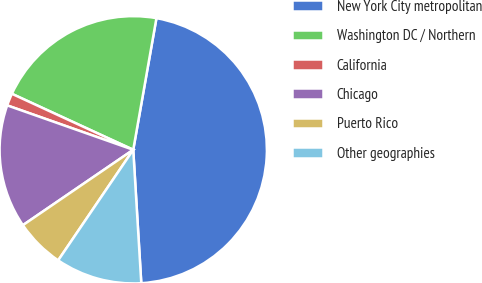Convert chart. <chart><loc_0><loc_0><loc_500><loc_500><pie_chart><fcel>New York City metropolitan<fcel>Washington DC / Northern<fcel>California<fcel>Chicago<fcel>Puerto Rico<fcel>Other geographies<nl><fcel>46.27%<fcel>20.9%<fcel>1.49%<fcel>14.93%<fcel>5.97%<fcel>10.45%<nl></chart> 